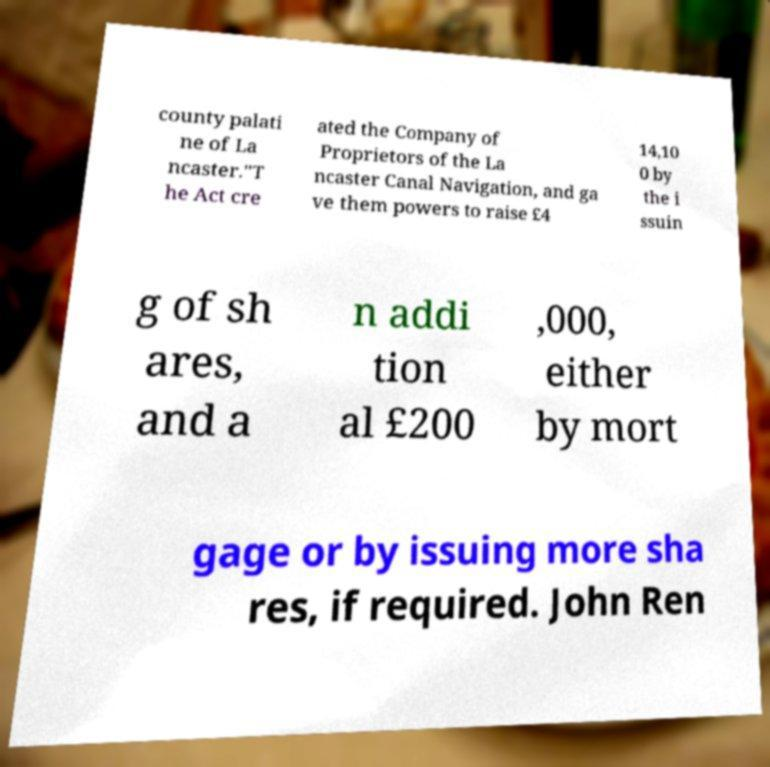Please identify and transcribe the text found in this image. county palati ne of La ncaster."T he Act cre ated the Company of Proprietors of the La ncaster Canal Navigation, and ga ve them powers to raise £4 14,10 0 by the i ssuin g of sh ares, and a n addi tion al £200 ,000, either by mort gage or by issuing more sha res, if required. John Ren 